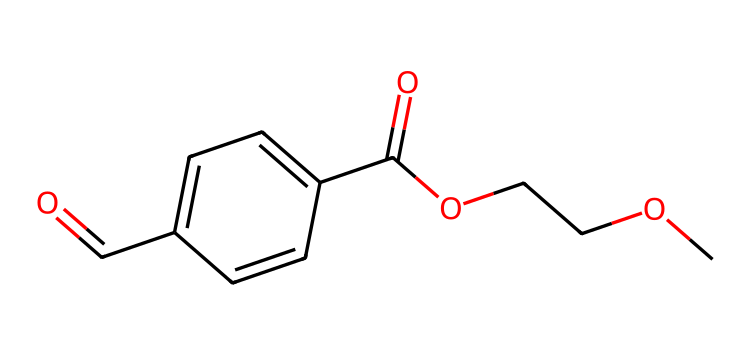What is the total number of carbon atoms in the chemical structure? The SMILES representation indicates several carbon atoms. By counting each 'C', we find there are 6 carbon atoms in the structure.
Answer: 6 How many ester linkages are present in the chemical? In the SMILES, there is one 'C(=O)O' and 'OCC', indicating a single ester functional group, thus there is one ester linkage.
Answer: 1 What type of bond connects the carboxylic acid and the ester in this structure? The carboxylic acid part features a C(=O)O and is linked to another carbon through a single bond, indicating it's a covalent bond.
Answer: covalent bond What functional groups can be identified in this chemical structure? Upon examining the SMILES, we see a carboxylic acid (-COOH) and an ester (-COO-), indicating these two distinct functional groups are present.
Answer: carboxylic acid and ester Does this chemical structure indicate any aromaticity? The presence of a 'c' in the representation indicating the connected carbon atoms in a ring suggests aromaticity is present, as these denote carbon atoms in an aromatic or cyclic structure.
Answer: yes What is the significance of the ester group in PET plastic used in packaging? The ester group plays a crucial role in the properties of PET, as it contributes to the thermoplastic behavior, allowing the material to be moldable when heated and to retain its shape upon cooling.
Answer: thermoplastic behavior 